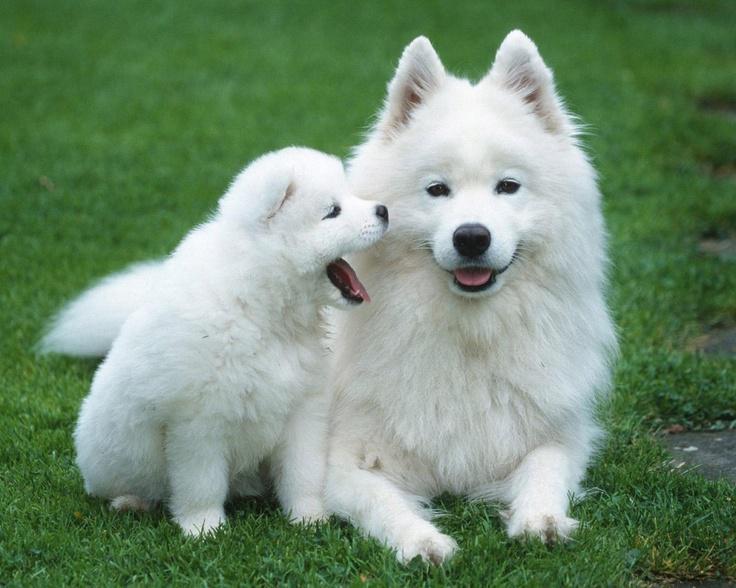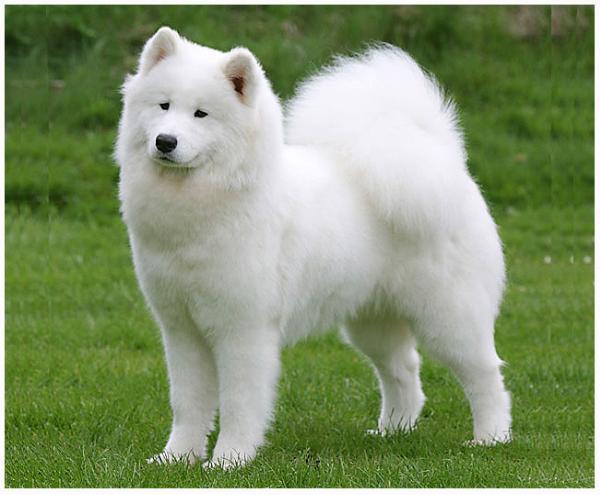The first image is the image on the left, the second image is the image on the right. Evaluate the accuracy of this statement regarding the images: "There is a ball or a backpack in atleast one of the pictures.". Is it true? Answer yes or no. No. 